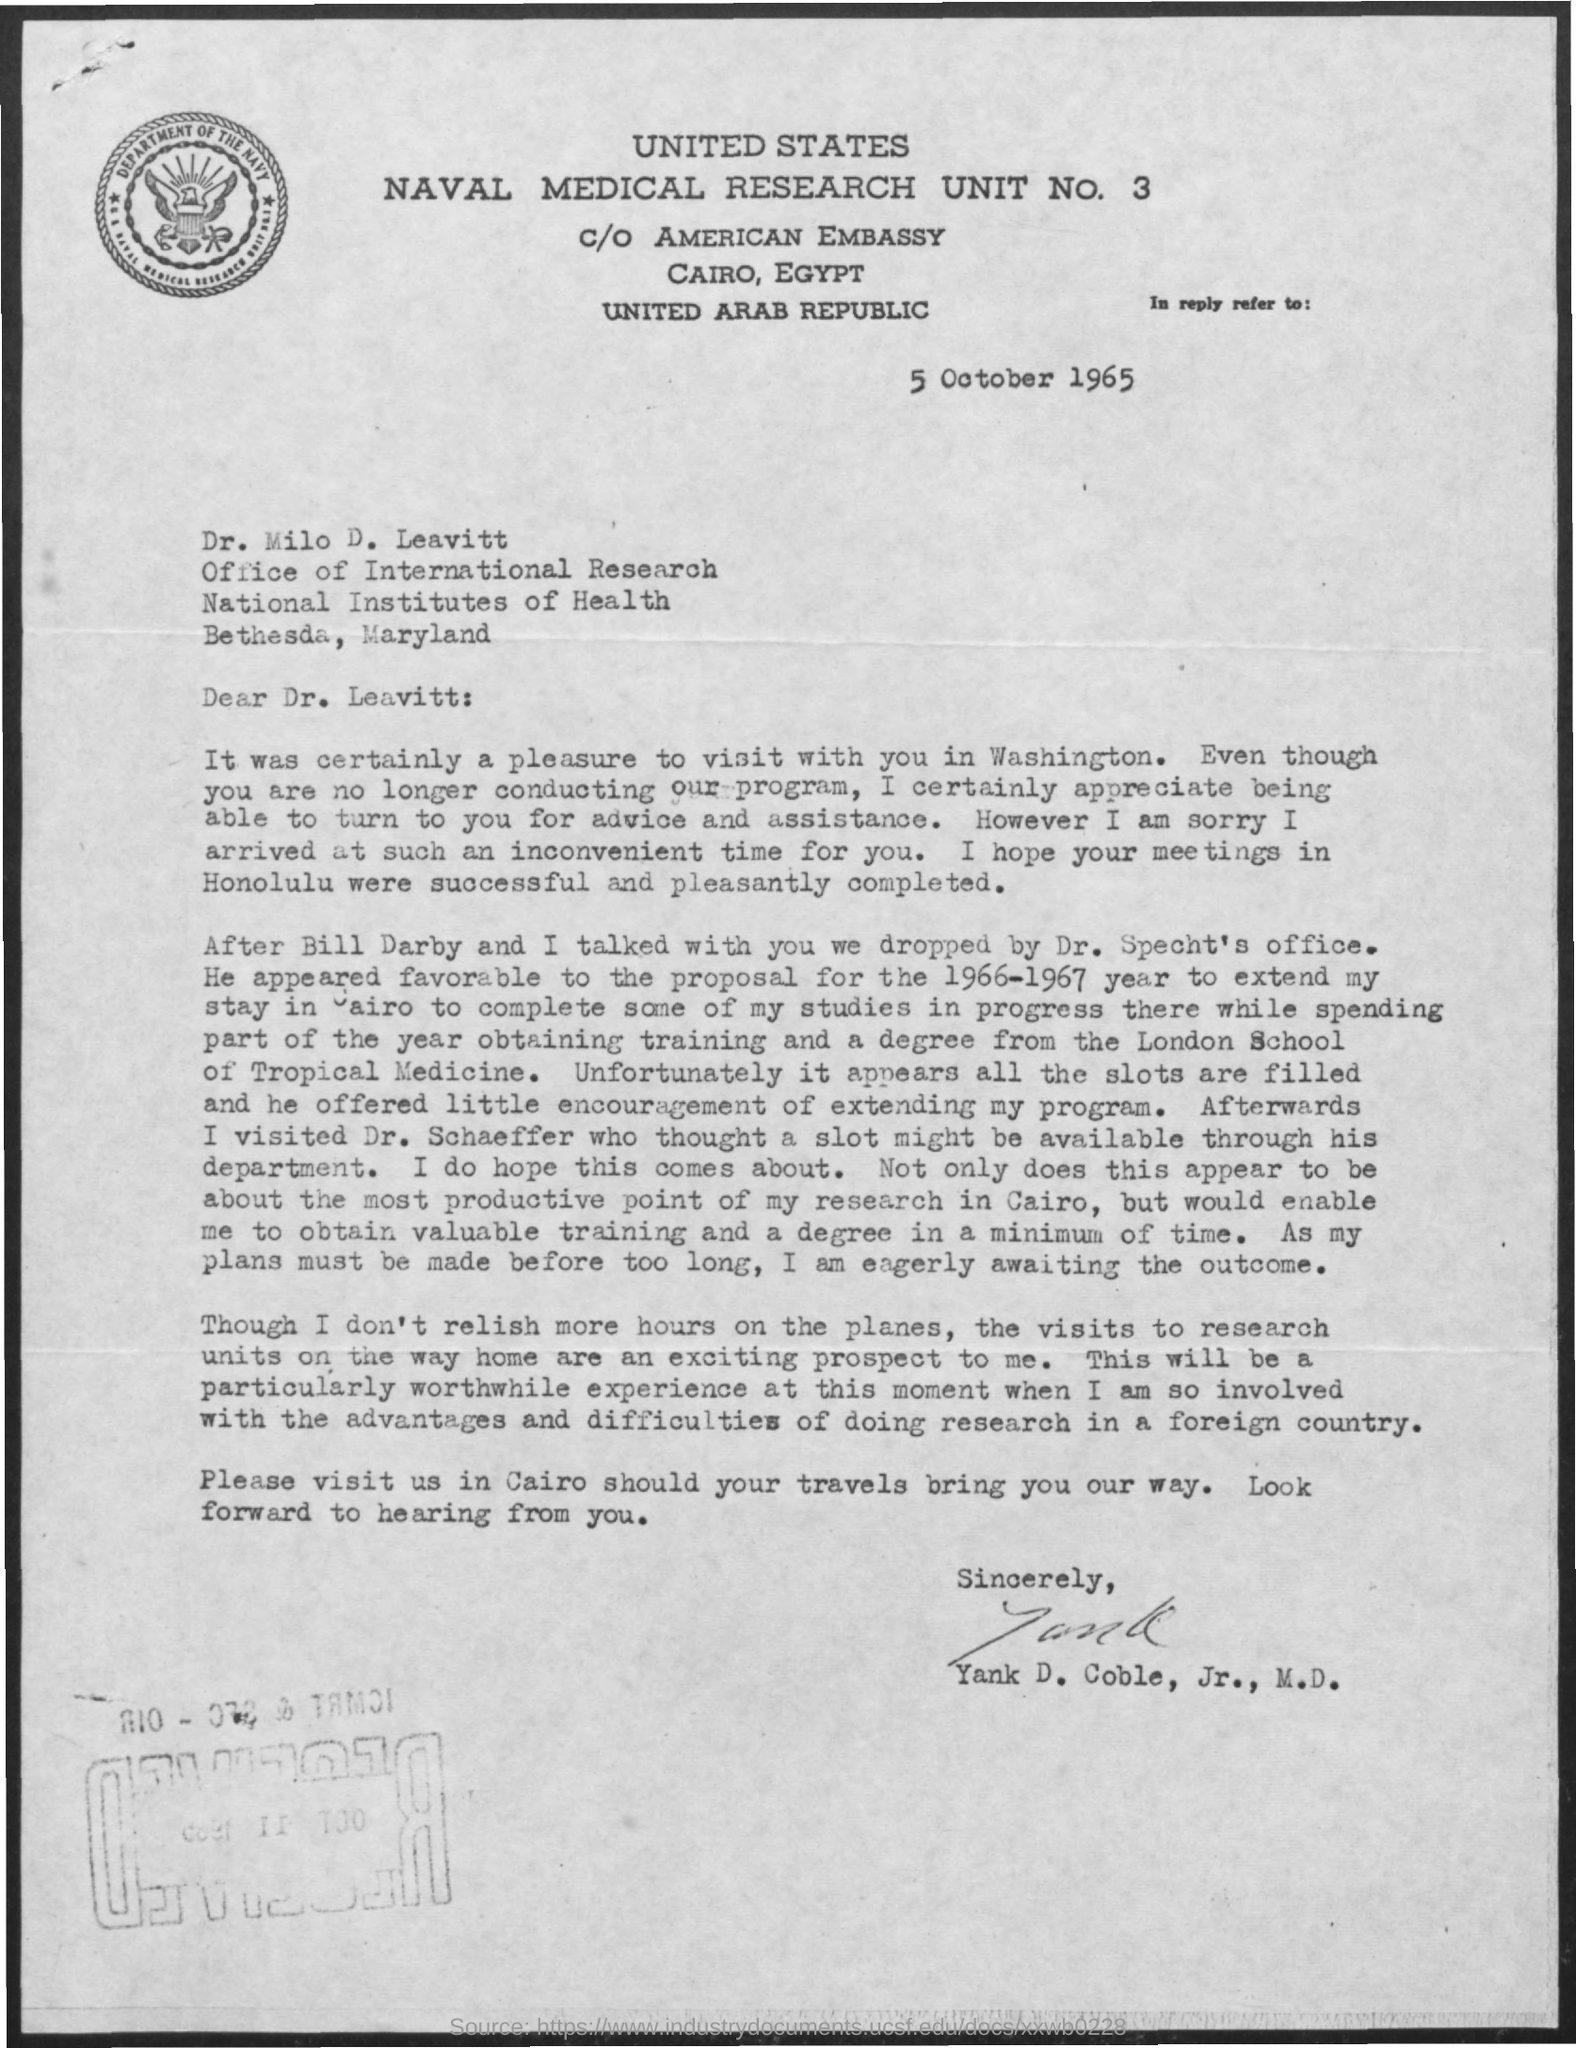Highlight a few significant elements in this photo. This letter is addressed to Dr. Leavitt. The date mentioned is 5 October 1965. 